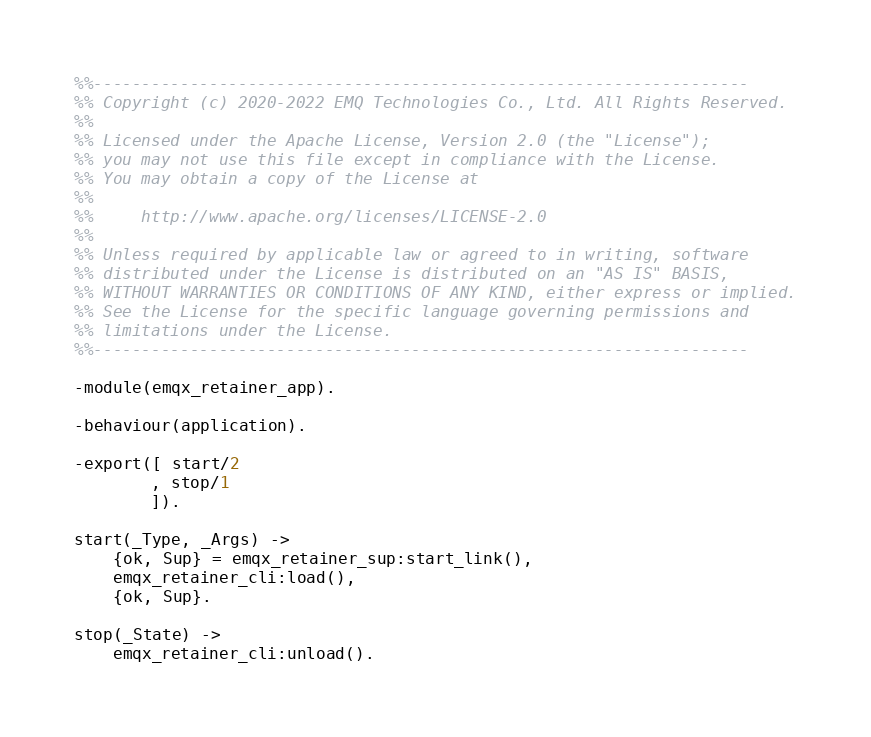Convert code to text. <code><loc_0><loc_0><loc_500><loc_500><_Erlang_>%%--------------------------------------------------------------------
%% Copyright (c) 2020-2022 EMQ Technologies Co., Ltd. All Rights Reserved.
%%
%% Licensed under the Apache License, Version 2.0 (the "License");
%% you may not use this file except in compliance with the License.
%% You may obtain a copy of the License at
%%
%%     http://www.apache.org/licenses/LICENSE-2.0
%%
%% Unless required by applicable law or agreed to in writing, software
%% distributed under the License is distributed on an "AS IS" BASIS,
%% WITHOUT WARRANTIES OR CONDITIONS OF ANY KIND, either express or implied.
%% See the License for the specific language governing permissions and
%% limitations under the License.
%%--------------------------------------------------------------------

-module(emqx_retainer_app).

-behaviour(application).

-export([ start/2
        , stop/1
        ]).

start(_Type, _Args) ->
    {ok, Sup} = emqx_retainer_sup:start_link(),
    emqx_retainer_cli:load(),
    {ok, Sup}.

stop(_State) ->
    emqx_retainer_cli:unload().

</code> 